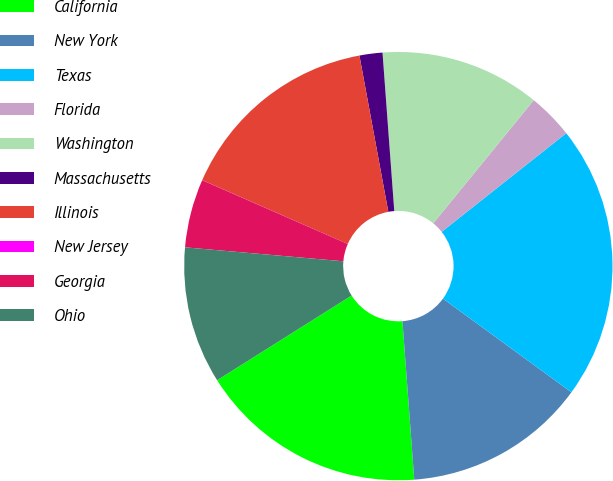Convert chart. <chart><loc_0><loc_0><loc_500><loc_500><pie_chart><fcel>California<fcel>New York<fcel>Texas<fcel>Florida<fcel>Washington<fcel>Massachusetts<fcel>Illinois<fcel>New Jersey<fcel>Georgia<fcel>Ohio<nl><fcel>17.24%<fcel>13.79%<fcel>20.68%<fcel>3.45%<fcel>12.07%<fcel>1.73%<fcel>15.51%<fcel>0.01%<fcel>5.17%<fcel>10.34%<nl></chart> 